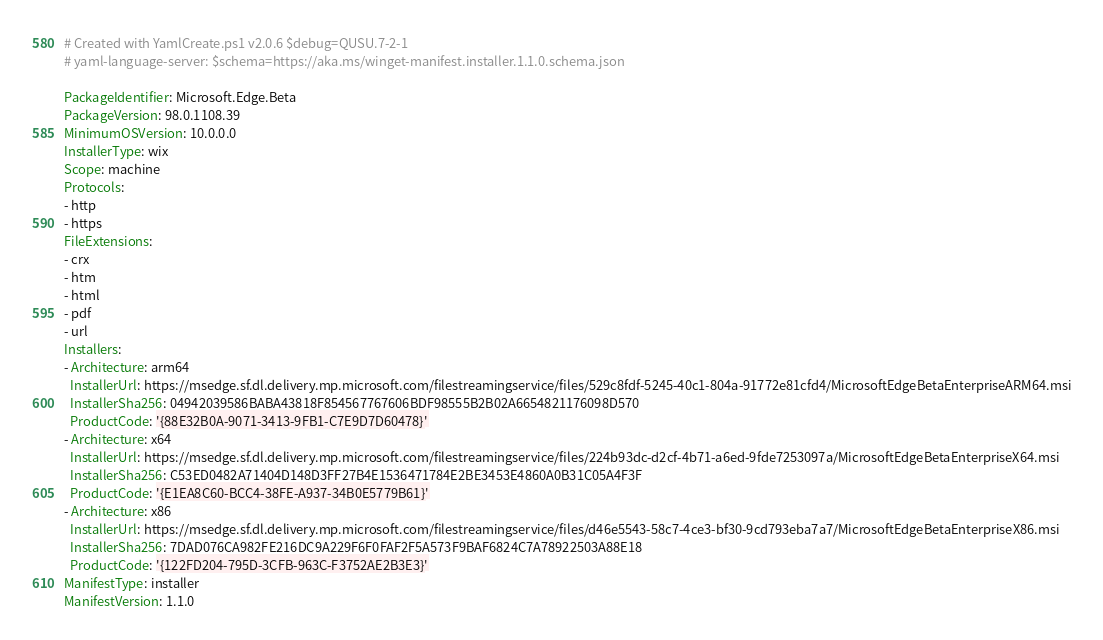Convert code to text. <code><loc_0><loc_0><loc_500><loc_500><_YAML_># Created with YamlCreate.ps1 v2.0.6 $debug=QUSU.7-2-1
# yaml-language-server: $schema=https://aka.ms/winget-manifest.installer.1.1.0.schema.json

PackageIdentifier: Microsoft.Edge.Beta
PackageVersion: 98.0.1108.39
MinimumOSVersion: 10.0.0.0
InstallerType: wix
Scope: machine
Protocols:
- http
- https
FileExtensions:
- crx
- htm
- html
- pdf
- url
Installers:
- Architecture: arm64
  InstallerUrl: https://msedge.sf.dl.delivery.mp.microsoft.com/filestreamingservice/files/529c8fdf-5245-40c1-804a-91772e81cfd4/MicrosoftEdgeBetaEnterpriseARM64.msi
  InstallerSha256: 04942039586BABA43818F854567767606BDF98555B2B02A6654821176098D570
  ProductCode: '{88E32B0A-9071-3413-9FB1-C7E9D7D60478}'
- Architecture: x64
  InstallerUrl: https://msedge.sf.dl.delivery.mp.microsoft.com/filestreamingservice/files/224b93dc-d2cf-4b71-a6ed-9fde7253097a/MicrosoftEdgeBetaEnterpriseX64.msi
  InstallerSha256: C53ED0482A71404D148D3FF27B4E1536471784E2BE3453E4860A0B31C05A4F3F
  ProductCode: '{E1EA8C60-BCC4-38FE-A937-34B0E5779B61}'
- Architecture: x86
  InstallerUrl: https://msedge.sf.dl.delivery.mp.microsoft.com/filestreamingservice/files/d46e5543-58c7-4ce3-bf30-9cd793eba7a7/MicrosoftEdgeBetaEnterpriseX86.msi
  InstallerSha256: 7DAD076CA982FE216DC9A229F6F0FAF2F5A573F9BAF6824C7A78922503A88E18
  ProductCode: '{122FD204-795D-3CFB-963C-F3752AE2B3E3}'
ManifestType: installer
ManifestVersion: 1.1.0
</code> 